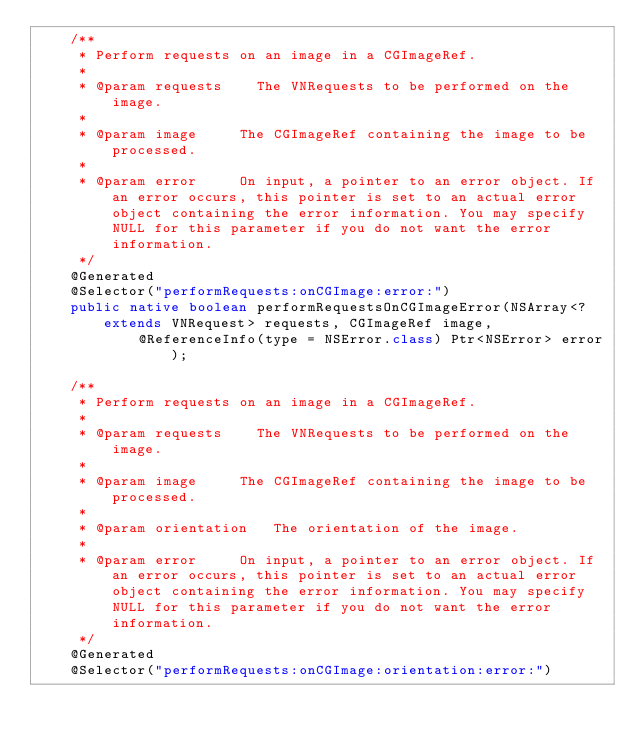Convert code to text. <code><loc_0><loc_0><loc_500><loc_500><_Java_>    /**
     * Perform requests on an image in a CGImageRef.
     * 
     * @param	requests		The VNRequests to be performed on the image.
     * 
     * @param	image			The CGImageRef containing the image to be processed.
     * 
     * @param	error			On input, a pointer to an error object. If an error occurs, this pointer is set to an actual error object containing the error information. You may specify NULL for this parameter if you do not want the error information.
     */
    @Generated
    @Selector("performRequests:onCGImage:error:")
    public native boolean performRequestsOnCGImageError(NSArray<? extends VNRequest> requests, CGImageRef image,
            @ReferenceInfo(type = NSError.class) Ptr<NSError> error);

    /**
     * Perform requests on an image in a CGImageRef.
     * 
     * @param	requests		The VNRequests to be performed on the image.
     * 
     * @param	image			The CGImageRef containing the image to be processed.
     * 
     * @param	orientation		The orientation of the image.
     * 
     * @param	error			On input, a pointer to an error object. If an error occurs, this pointer is set to an actual error object containing the error information. You may specify NULL for this parameter if you do not want the error information.
     */
    @Generated
    @Selector("performRequests:onCGImage:orientation:error:")</code> 